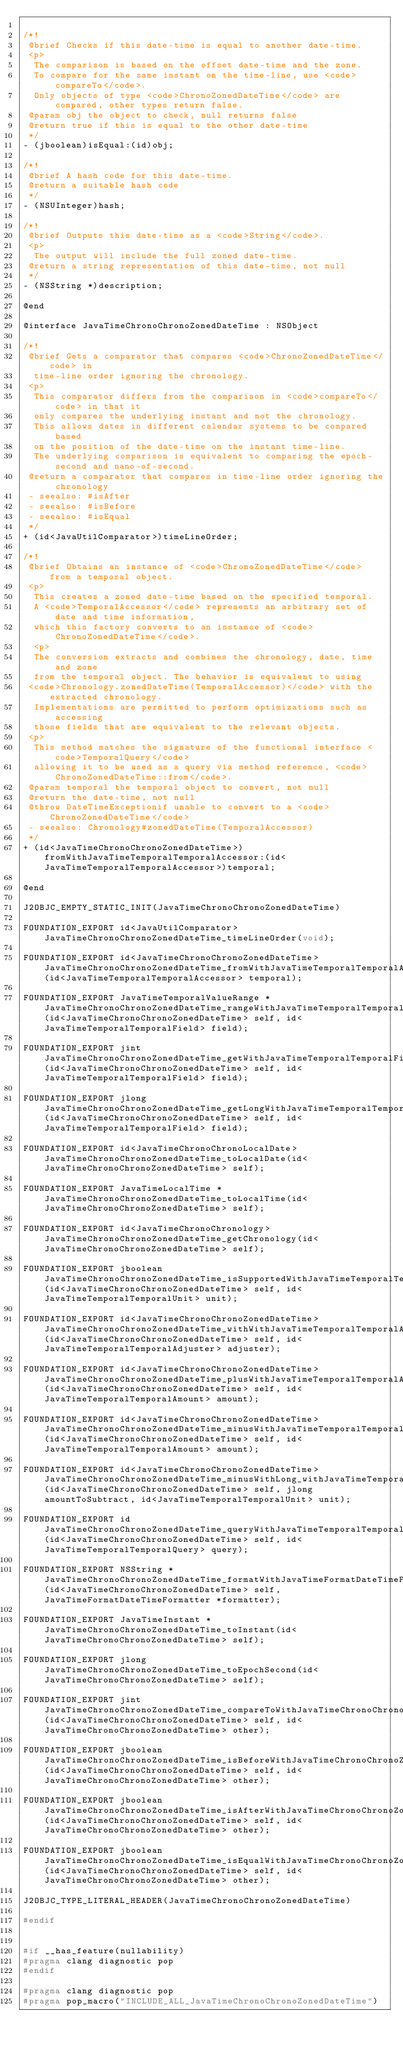Convert code to text. <code><loc_0><loc_0><loc_500><loc_500><_C_>
/*!
 @brief Checks if this date-time is equal to another date-time.
 <p>
  The comparison is based on the offset date-time and the zone.
  To compare for the same instant on the time-line, use <code>compareTo</code>.
  Only objects of type <code>ChronoZonedDateTime</code> are compared, other types return false.
 @param obj the object to check, null returns false
 @return true if this is equal to the other date-time
 */
- (jboolean)isEqual:(id)obj;

/*!
 @brief A hash code for this date-time.
 @return a suitable hash code
 */
- (NSUInteger)hash;

/*!
 @brief Outputs this date-time as a <code>String</code>.
 <p>
  The output will include the full zoned date-time.
 @return a string representation of this date-time, not null
 */
- (NSString *)description;

@end

@interface JavaTimeChronoChronoZonedDateTime : NSObject

/*!
 @brief Gets a comparator that compares <code>ChronoZonedDateTime</code> in
  time-line order ignoring the chronology.
 <p>
  This comparator differs from the comparison in <code>compareTo</code> in that it
  only compares the underlying instant and not the chronology.
  This allows dates in different calendar systems to be compared based
  on the position of the date-time on the instant time-line.
  The underlying comparison is equivalent to comparing the epoch-second and nano-of-second.
 @return a comparator that compares in time-line order ignoring the chronology
 - seealso: #isAfter
 - seealso: #isBefore
 - seealso: #isEqual
 */
+ (id<JavaUtilComparator>)timeLineOrder;

/*!
 @brief Obtains an instance of <code>ChronoZonedDateTime</code> from a temporal object.
 <p>
  This creates a zoned date-time based on the specified temporal.
  A <code>TemporalAccessor</code> represents an arbitrary set of date and time information,
  which this factory converts to an instance of <code>ChronoZonedDateTime</code>.
  <p>
  The conversion extracts and combines the chronology, date, time and zone
  from the temporal object. The behavior is equivalent to using 
 <code>Chronology.zonedDateTime(TemporalAccessor)</code> with the extracted chronology.
  Implementations are permitted to perform optimizations such as accessing
  those fields that are equivalent to the relevant objects. 
 <p>
  This method matches the signature of the functional interface <code>TemporalQuery</code>
  allowing it to be used as a query via method reference, <code>ChronoZonedDateTime::from</code>.
 @param temporal the temporal object to convert, not null
 @return the date-time, not null
 @throw DateTimeExceptionif unable to convert to a <code>ChronoZonedDateTime</code>
 - seealso: Chronology#zonedDateTime(TemporalAccessor)
 */
+ (id<JavaTimeChronoChronoZonedDateTime>)fromWithJavaTimeTemporalTemporalAccessor:(id<JavaTimeTemporalTemporalAccessor>)temporal;

@end

J2OBJC_EMPTY_STATIC_INIT(JavaTimeChronoChronoZonedDateTime)

FOUNDATION_EXPORT id<JavaUtilComparator> JavaTimeChronoChronoZonedDateTime_timeLineOrder(void);

FOUNDATION_EXPORT id<JavaTimeChronoChronoZonedDateTime> JavaTimeChronoChronoZonedDateTime_fromWithJavaTimeTemporalTemporalAccessor_(id<JavaTimeTemporalTemporalAccessor> temporal);

FOUNDATION_EXPORT JavaTimeTemporalValueRange *JavaTimeChronoChronoZonedDateTime_rangeWithJavaTimeTemporalTemporalField_(id<JavaTimeChronoChronoZonedDateTime> self, id<JavaTimeTemporalTemporalField> field);

FOUNDATION_EXPORT jint JavaTimeChronoChronoZonedDateTime_getWithJavaTimeTemporalTemporalField_(id<JavaTimeChronoChronoZonedDateTime> self, id<JavaTimeTemporalTemporalField> field);

FOUNDATION_EXPORT jlong JavaTimeChronoChronoZonedDateTime_getLongWithJavaTimeTemporalTemporalField_(id<JavaTimeChronoChronoZonedDateTime> self, id<JavaTimeTemporalTemporalField> field);

FOUNDATION_EXPORT id<JavaTimeChronoChronoLocalDate> JavaTimeChronoChronoZonedDateTime_toLocalDate(id<JavaTimeChronoChronoZonedDateTime> self);

FOUNDATION_EXPORT JavaTimeLocalTime *JavaTimeChronoChronoZonedDateTime_toLocalTime(id<JavaTimeChronoChronoZonedDateTime> self);

FOUNDATION_EXPORT id<JavaTimeChronoChronology> JavaTimeChronoChronoZonedDateTime_getChronology(id<JavaTimeChronoChronoZonedDateTime> self);

FOUNDATION_EXPORT jboolean JavaTimeChronoChronoZonedDateTime_isSupportedWithJavaTimeTemporalTemporalUnit_(id<JavaTimeChronoChronoZonedDateTime> self, id<JavaTimeTemporalTemporalUnit> unit);

FOUNDATION_EXPORT id<JavaTimeChronoChronoZonedDateTime> JavaTimeChronoChronoZonedDateTime_withWithJavaTimeTemporalTemporalAdjuster_(id<JavaTimeChronoChronoZonedDateTime> self, id<JavaTimeTemporalTemporalAdjuster> adjuster);

FOUNDATION_EXPORT id<JavaTimeChronoChronoZonedDateTime> JavaTimeChronoChronoZonedDateTime_plusWithJavaTimeTemporalTemporalAmount_(id<JavaTimeChronoChronoZonedDateTime> self, id<JavaTimeTemporalTemporalAmount> amount);

FOUNDATION_EXPORT id<JavaTimeChronoChronoZonedDateTime> JavaTimeChronoChronoZonedDateTime_minusWithJavaTimeTemporalTemporalAmount_(id<JavaTimeChronoChronoZonedDateTime> self, id<JavaTimeTemporalTemporalAmount> amount);

FOUNDATION_EXPORT id<JavaTimeChronoChronoZonedDateTime> JavaTimeChronoChronoZonedDateTime_minusWithLong_withJavaTimeTemporalTemporalUnit_(id<JavaTimeChronoChronoZonedDateTime> self, jlong amountToSubtract, id<JavaTimeTemporalTemporalUnit> unit);

FOUNDATION_EXPORT id JavaTimeChronoChronoZonedDateTime_queryWithJavaTimeTemporalTemporalQuery_(id<JavaTimeChronoChronoZonedDateTime> self, id<JavaTimeTemporalTemporalQuery> query);

FOUNDATION_EXPORT NSString *JavaTimeChronoChronoZonedDateTime_formatWithJavaTimeFormatDateTimeFormatter_(id<JavaTimeChronoChronoZonedDateTime> self, JavaTimeFormatDateTimeFormatter *formatter);

FOUNDATION_EXPORT JavaTimeInstant *JavaTimeChronoChronoZonedDateTime_toInstant(id<JavaTimeChronoChronoZonedDateTime> self);

FOUNDATION_EXPORT jlong JavaTimeChronoChronoZonedDateTime_toEpochSecond(id<JavaTimeChronoChronoZonedDateTime> self);

FOUNDATION_EXPORT jint JavaTimeChronoChronoZonedDateTime_compareToWithJavaTimeChronoChronoZonedDateTime_(id<JavaTimeChronoChronoZonedDateTime> self, id<JavaTimeChronoChronoZonedDateTime> other);

FOUNDATION_EXPORT jboolean JavaTimeChronoChronoZonedDateTime_isBeforeWithJavaTimeChronoChronoZonedDateTime_(id<JavaTimeChronoChronoZonedDateTime> self, id<JavaTimeChronoChronoZonedDateTime> other);

FOUNDATION_EXPORT jboolean JavaTimeChronoChronoZonedDateTime_isAfterWithJavaTimeChronoChronoZonedDateTime_(id<JavaTimeChronoChronoZonedDateTime> self, id<JavaTimeChronoChronoZonedDateTime> other);

FOUNDATION_EXPORT jboolean JavaTimeChronoChronoZonedDateTime_isEqualWithJavaTimeChronoChronoZonedDateTime_(id<JavaTimeChronoChronoZonedDateTime> self, id<JavaTimeChronoChronoZonedDateTime> other);

J2OBJC_TYPE_LITERAL_HEADER(JavaTimeChronoChronoZonedDateTime)

#endif


#if __has_feature(nullability)
#pragma clang diagnostic pop
#endif

#pragma clang diagnostic pop
#pragma pop_macro("INCLUDE_ALL_JavaTimeChronoChronoZonedDateTime")
</code> 